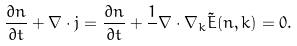<formula> <loc_0><loc_0><loc_500><loc_500>\frac { { \partial } { n } } { \partial t } + \nabla \cdot { j } = \frac { { \partial } { n } } { \partial t } + \frac { 1 } { } \nabla \cdot \nabla _ { k } { \tilde { E } } ( { n } , { k } ) = 0 .</formula> 